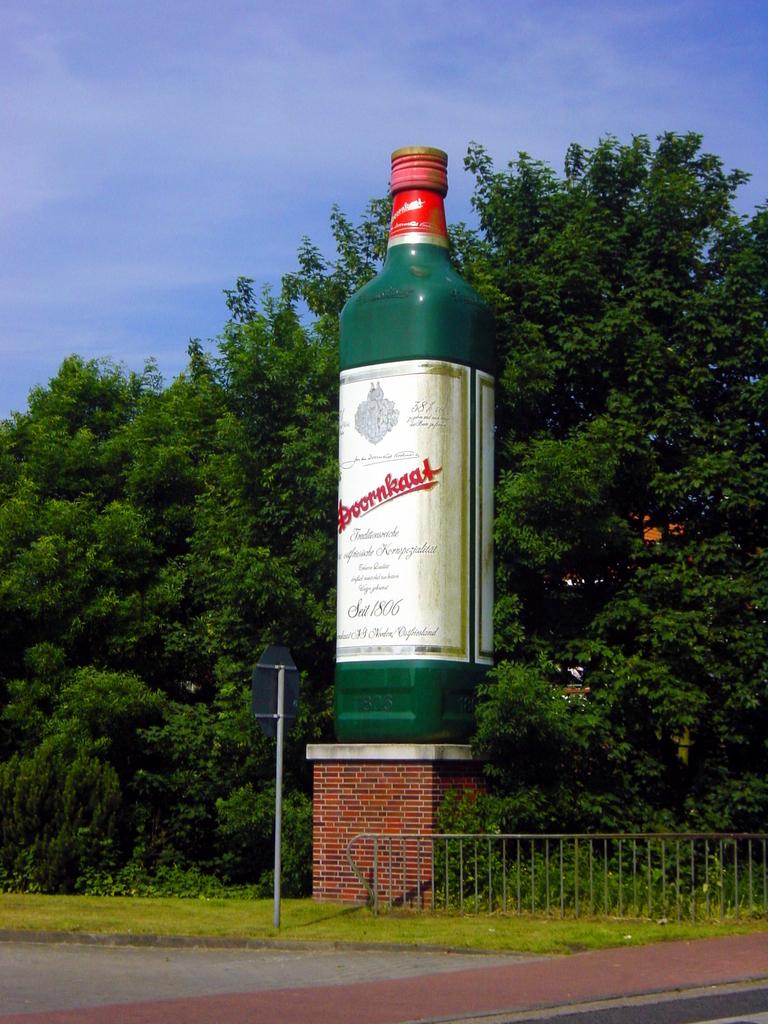What year is on the bottle?
Ensure brevity in your answer.  1806. 